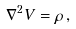Convert formula to latex. <formula><loc_0><loc_0><loc_500><loc_500>\nabla ^ { 2 } V = \rho \, ,</formula> 